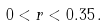Convert formula to latex. <formula><loc_0><loc_0><loc_500><loc_500>0 < r < 0 . 3 5 \, .</formula> 